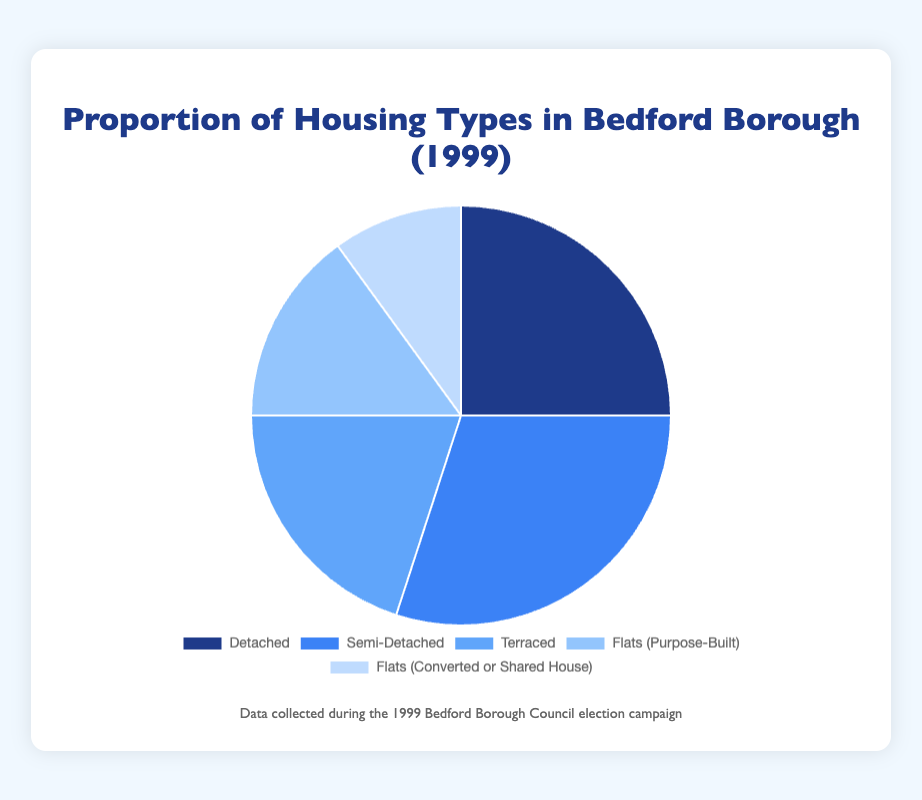What is the most common housing type in Bedford Borough in 1999? The figure shows the proportion of each housing type. The sector representing "Semi-Detached" housing is the largest, indicating it is the most common type.
Answer: Semi-Detached Which two housing types together make up exactly half of the housing types? By adding the proportions, Semi-Detached (30%) and Detached (25%) together make 55%, which is greater than half. Next, Semi-Detached (30%) and Terraced (20%) add up to 50%, which is exactly half of the total housing types.
Answer: Semi-Detached and Terraced Which housing type is the least common in Bedford Borough in 1999? The smallest sector in the pie chart represents "Flats (Converted or Shared House)," indicating it is the least common housing type.
Answer: Flats (Converted or Shared House) Compare the proportion of Detached housing to Flats (Purpose-Built). Which has a higher proportion and by how much? The proportion of Detached housing is 25%, and the proportion of Flats (Purpose-Built) is 15%. Subtracting 15% from 25% gives 10%.
Answer: Detached has a higher proportion by 10% What is the combined proportion of all Flats in Bedford Borough in 1999? There are two categories of Flats: Purpose-Built (15%) and Converted or Shared House (10%). Adding these together gives 15% + 10% = 25%.
Answer: 25% What percentage of the housing types are not Flats? The total proportion for Flats (Purpose-Built and Converted or Shared House) is 25%. Therefore, the proportion of housing types that are not Flats is 100% - 25% = 75%.
Answer: 75% If you were to choose a housing type randomly, what is the probability it would be Terraced or Detached? The probability is the sum of the proportions of Terraced (20%) and Detached (25%). Adding these together gives 20% + 25% = 45%.
Answer: 45% What is the difference in proportion between Semi-Detached and Terraced housing? The proportion of Semi-Detached housing is 30% and Terraced housing is 20%. Subtracting 20% from 30% gives a difference of 10%.
Answer: 10% Which housing type has the second-highest proportion? The sector representing "Detached" housing is the second largest, following the "Semi-Detached" sector.
Answer: Detached 